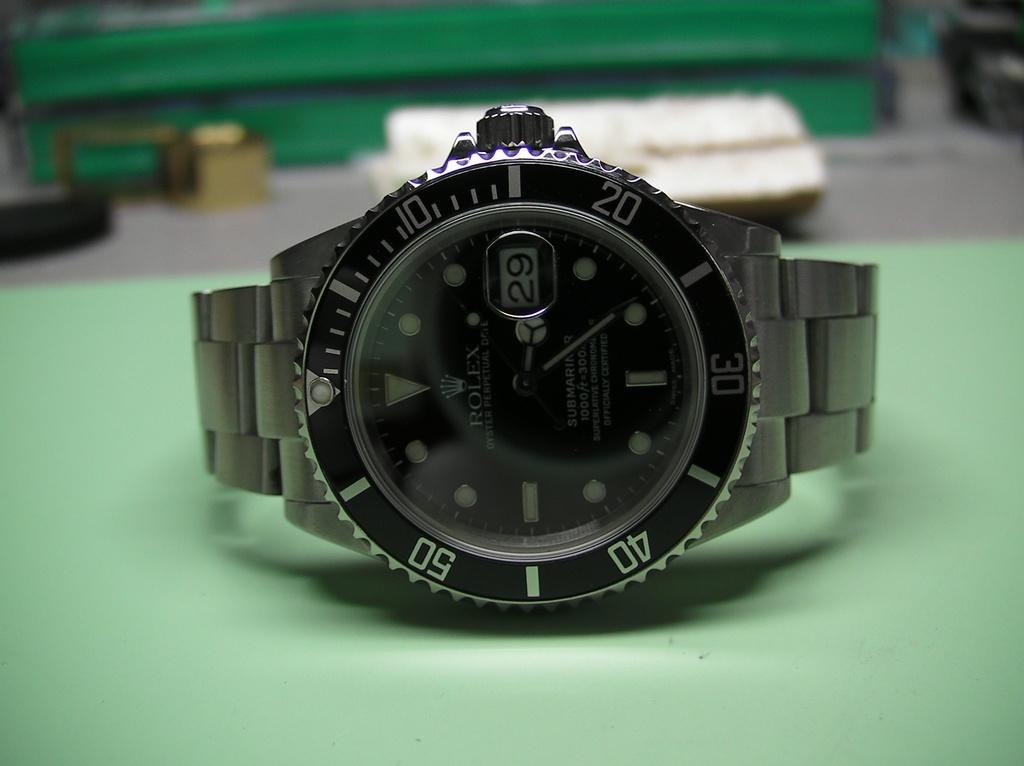<image>
Give a short and clear explanation of the subsequent image. A Rolex watch laying on its side on a green surface. 